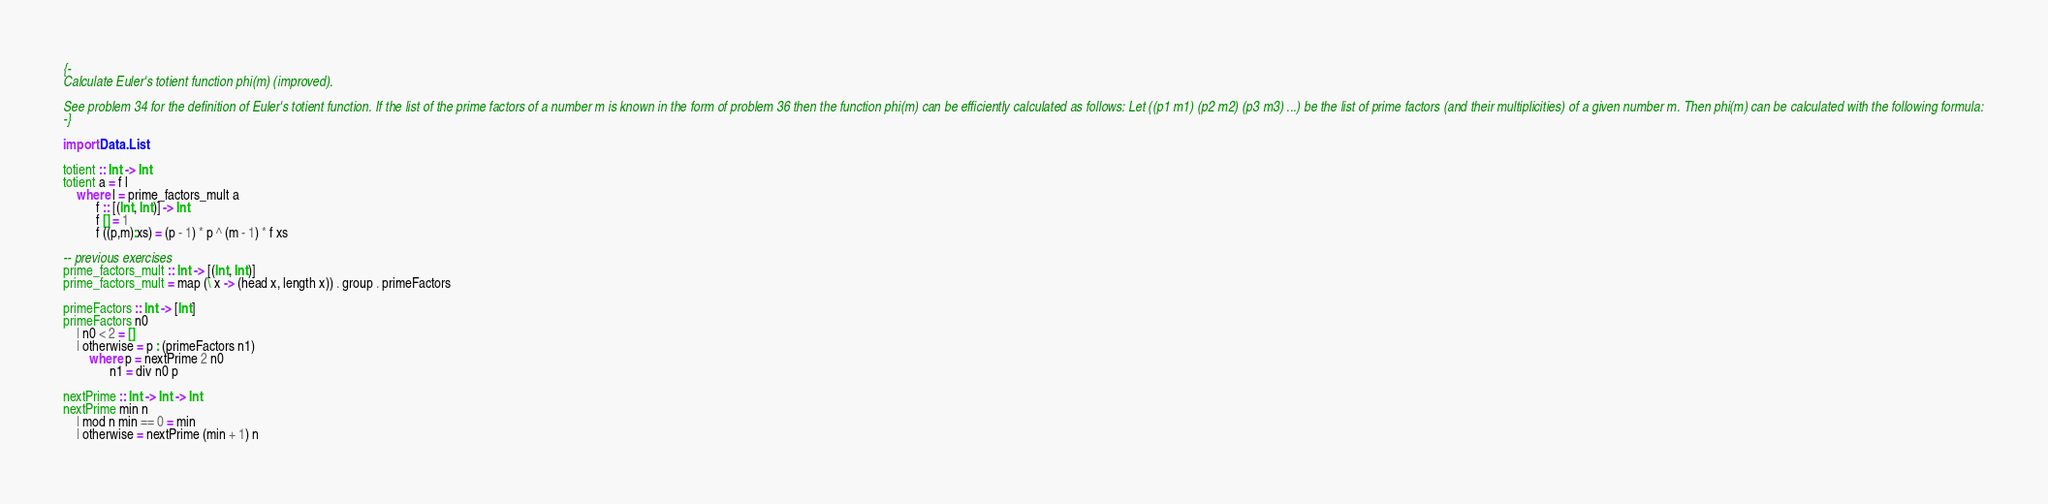Convert code to text. <code><loc_0><loc_0><loc_500><loc_500><_Haskell_>{-
Calculate Euler's totient function phi(m) (improved).

See problem 34 for the definition of Euler's totient function. If the list of the prime factors of a number m is known in the form of problem 36 then the function phi(m) can be efficiently calculated as follows: Let ((p1 m1) (p2 m2) (p3 m3) ...) be the list of prime factors (and their multiplicities) of a given number m. Then phi(m) can be calculated with the following formula:
-}

import Data.List

totient :: Int -> Int
totient a = f l
    where l = prime_factors_mult a
          f :: [(Int, Int)] -> Int
          f [] = 1
          f ((p,m):xs) = (p - 1) * p ^ (m - 1) * f xs

-- previous exercises
prime_factors_mult :: Int -> [(Int, Int)]
prime_factors_mult = map (\ x -> (head x, length x)) . group . primeFactors

primeFactors :: Int -> [Int]
primeFactors n0
    | n0 < 2 = []
    | otherwise = p : (primeFactors n1)
        where p = nextPrime 2 n0
              n1 = div n0 p

nextPrime :: Int -> Int -> Int
nextPrime min n 
    | mod n min == 0 = min
    | otherwise = nextPrime (min + 1) n
</code> 